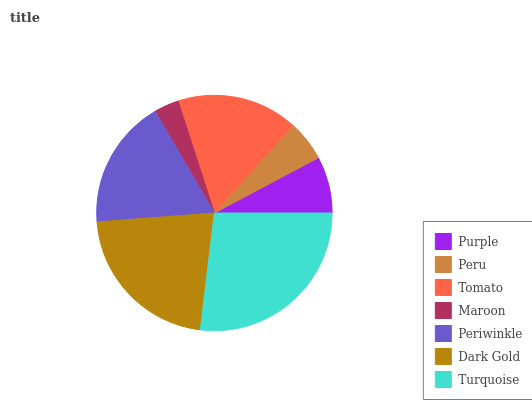Is Maroon the minimum?
Answer yes or no. Yes. Is Turquoise the maximum?
Answer yes or no. Yes. Is Peru the minimum?
Answer yes or no. No. Is Peru the maximum?
Answer yes or no. No. Is Purple greater than Peru?
Answer yes or no. Yes. Is Peru less than Purple?
Answer yes or no. Yes. Is Peru greater than Purple?
Answer yes or no. No. Is Purple less than Peru?
Answer yes or no. No. Is Tomato the high median?
Answer yes or no. Yes. Is Tomato the low median?
Answer yes or no. Yes. Is Periwinkle the high median?
Answer yes or no. No. Is Purple the low median?
Answer yes or no. No. 